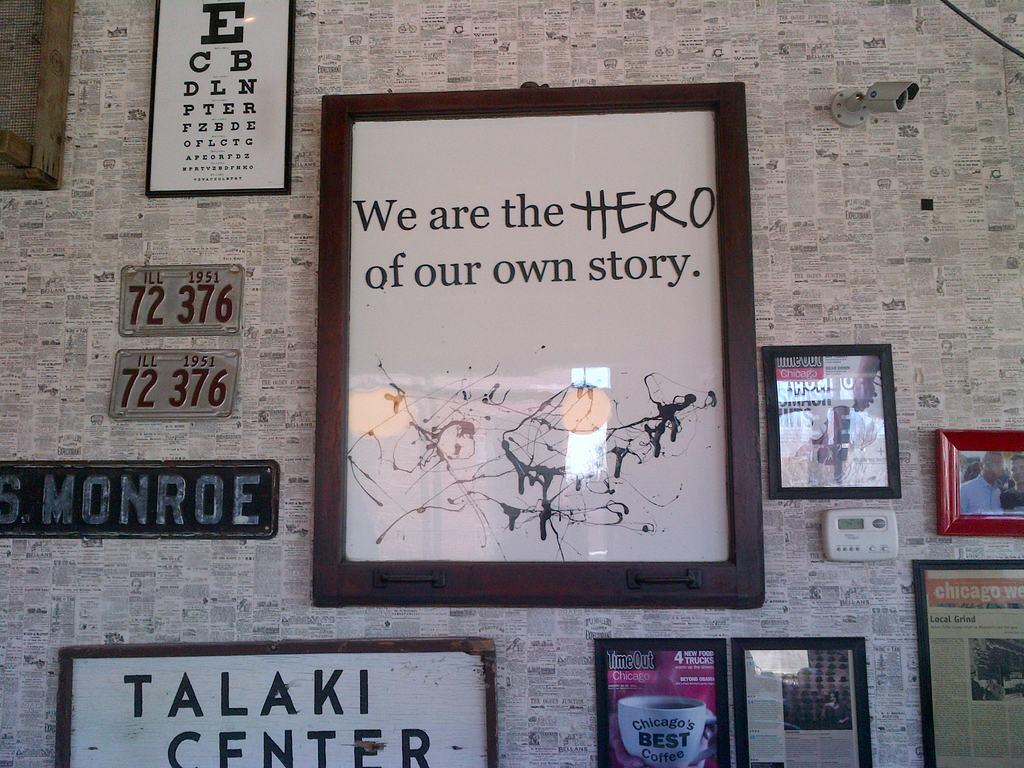What is our role in our own story?
Your answer should be compact. Hero. What is the number of the license plates?
Make the answer very short. 72 376. 